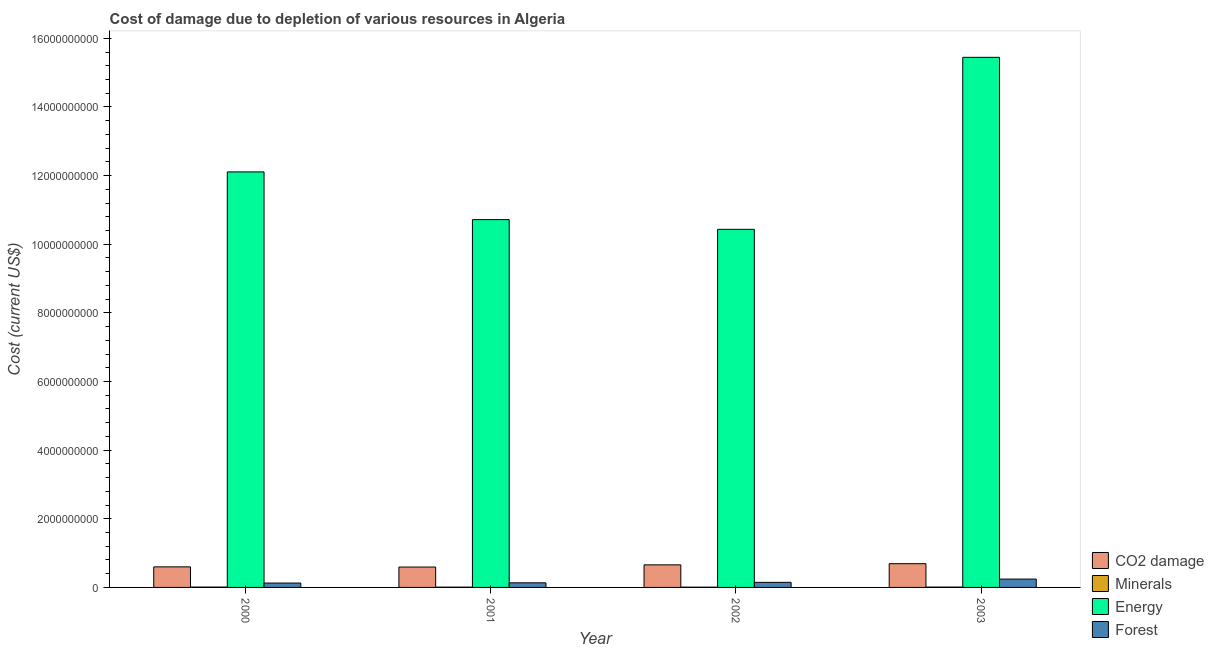How many different coloured bars are there?
Provide a succinct answer. 4. How many groups of bars are there?
Offer a terse response. 4. How many bars are there on the 2nd tick from the left?
Offer a terse response. 4. What is the label of the 1st group of bars from the left?
Keep it short and to the point. 2000. In how many cases, is the number of bars for a given year not equal to the number of legend labels?
Your answer should be compact. 0. What is the cost of damage due to depletion of energy in 2003?
Ensure brevity in your answer.  1.54e+1. Across all years, what is the maximum cost of damage due to depletion of forests?
Give a very brief answer. 2.43e+08. Across all years, what is the minimum cost of damage due to depletion of forests?
Offer a terse response. 1.27e+08. What is the total cost of damage due to depletion of forests in the graph?
Provide a succinct answer. 6.53e+08. What is the difference between the cost of damage due to depletion of energy in 2000 and that in 2002?
Make the answer very short. 1.67e+09. What is the difference between the cost of damage due to depletion of coal in 2001 and the cost of damage due to depletion of minerals in 2002?
Ensure brevity in your answer.  -6.37e+07. What is the average cost of damage due to depletion of energy per year?
Your answer should be very brief. 1.22e+1. In the year 2001, what is the difference between the cost of damage due to depletion of forests and cost of damage due to depletion of energy?
Offer a very short reply. 0. In how many years, is the cost of damage due to depletion of forests greater than 13600000000 US$?
Your response must be concise. 0. What is the ratio of the cost of damage due to depletion of energy in 2002 to that in 2003?
Your response must be concise. 0.68. What is the difference between the highest and the second highest cost of damage due to depletion of minerals?
Provide a succinct answer. 5.20e+05. What is the difference between the highest and the lowest cost of damage due to depletion of energy?
Ensure brevity in your answer.  5.01e+09. In how many years, is the cost of damage due to depletion of minerals greater than the average cost of damage due to depletion of minerals taken over all years?
Make the answer very short. 2. Is the sum of the cost of damage due to depletion of energy in 2002 and 2003 greater than the maximum cost of damage due to depletion of minerals across all years?
Keep it short and to the point. Yes. What does the 3rd bar from the left in 2001 represents?
Make the answer very short. Energy. What does the 3rd bar from the right in 2003 represents?
Provide a succinct answer. Minerals. Is it the case that in every year, the sum of the cost of damage due to depletion of coal and cost of damage due to depletion of minerals is greater than the cost of damage due to depletion of energy?
Provide a succinct answer. No. How many bars are there?
Keep it short and to the point. 16. Are all the bars in the graph horizontal?
Provide a short and direct response. No. How many years are there in the graph?
Offer a very short reply. 4. What is the difference between two consecutive major ticks on the Y-axis?
Provide a short and direct response. 2.00e+09. Are the values on the major ticks of Y-axis written in scientific E-notation?
Ensure brevity in your answer.  No. Where does the legend appear in the graph?
Your answer should be very brief. Bottom right. How are the legend labels stacked?
Your response must be concise. Vertical. What is the title of the graph?
Offer a very short reply. Cost of damage due to depletion of various resources in Algeria . What is the label or title of the X-axis?
Offer a terse response. Year. What is the label or title of the Y-axis?
Your response must be concise. Cost (current US$). What is the Cost (current US$) in CO2 damage in 2000?
Give a very brief answer. 5.99e+08. What is the Cost (current US$) of Minerals in 2000?
Ensure brevity in your answer.  9.70e+06. What is the Cost (current US$) of Energy in 2000?
Your answer should be compact. 1.21e+1. What is the Cost (current US$) of Forest in 2000?
Offer a terse response. 1.27e+08. What is the Cost (current US$) of CO2 damage in 2001?
Offer a very short reply. 5.94e+08. What is the Cost (current US$) of Minerals in 2001?
Your answer should be compact. 8.20e+06. What is the Cost (current US$) in Energy in 2001?
Your response must be concise. 1.07e+1. What is the Cost (current US$) of Forest in 2001?
Give a very brief answer. 1.34e+08. What is the Cost (current US$) of CO2 damage in 2002?
Your answer should be very brief. 6.58e+08. What is the Cost (current US$) in Minerals in 2002?
Your response must be concise. 7.85e+06. What is the Cost (current US$) of Energy in 2002?
Offer a terse response. 1.04e+1. What is the Cost (current US$) in Forest in 2002?
Make the answer very short. 1.48e+08. What is the Cost (current US$) of CO2 damage in 2003?
Your answer should be very brief. 6.91e+08. What is the Cost (current US$) in Minerals in 2003?
Make the answer very short. 1.02e+07. What is the Cost (current US$) of Energy in 2003?
Ensure brevity in your answer.  1.54e+1. What is the Cost (current US$) in Forest in 2003?
Provide a short and direct response. 2.43e+08. Across all years, what is the maximum Cost (current US$) of CO2 damage?
Make the answer very short. 6.91e+08. Across all years, what is the maximum Cost (current US$) in Minerals?
Provide a succinct answer. 1.02e+07. Across all years, what is the maximum Cost (current US$) of Energy?
Provide a succinct answer. 1.54e+1. Across all years, what is the maximum Cost (current US$) of Forest?
Offer a very short reply. 2.43e+08. Across all years, what is the minimum Cost (current US$) in CO2 damage?
Offer a terse response. 5.94e+08. Across all years, what is the minimum Cost (current US$) in Minerals?
Offer a very short reply. 7.85e+06. Across all years, what is the minimum Cost (current US$) in Energy?
Provide a succinct answer. 1.04e+1. Across all years, what is the minimum Cost (current US$) in Forest?
Give a very brief answer. 1.27e+08. What is the total Cost (current US$) of CO2 damage in the graph?
Ensure brevity in your answer.  2.54e+09. What is the total Cost (current US$) in Minerals in the graph?
Your answer should be compact. 3.60e+07. What is the total Cost (current US$) of Energy in the graph?
Offer a terse response. 4.87e+1. What is the total Cost (current US$) of Forest in the graph?
Keep it short and to the point. 6.53e+08. What is the difference between the Cost (current US$) of CO2 damage in 2000 and that in 2001?
Your answer should be very brief. 4.80e+06. What is the difference between the Cost (current US$) in Minerals in 2000 and that in 2001?
Your answer should be very brief. 1.50e+06. What is the difference between the Cost (current US$) in Energy in 2000 and that in 2001?
Provide a short and direct response. 1.39e+09. What is the difference between the Cost (current US$) of Forest in 2000 and that in 2001?
Your response must be concise. -6.78e+06. What is the difference between the Cost (current US$) of CO2 damage in 2000 and that in 2002?
Give a very brief answer. -5.89e+07. What is the difference between the Cost (current US$) in Minerals in 2000 and that in 2002?
Make the answer very short. 1.84e+06. What is the difference between the Cost (current US$) of Energy in 2000 and that in 2002?
Ensure brevity in your answer.  1.67e+09. What is the difference between the Cost (current US$) of Forest in 2000 and that in 2002?
Provide a short and direct response. -2.07e+07. What is the difference between the Cost (current US$) of CO2 damage in 2000 and that in 2003?
Your answer should be compact. -9.25e+07. What is the difference between the Cost (current US$) of Minerals in 2000 and that in 2003?
Make the answer very short. -5.20e+05. What is the difference between the Cost (current US$) of Energy in 2000 and that in 2003?
Provide a succinct answer. -3.34e+09. What is the difference between the Cost (current US$) of Forest in 2000 and that in 2003?
Keep it short and to the point. -1.16e+08. What is the difference between the Cost (current US$) of CO2 damage in 2001 and that in 2002?
Provide a short and direct response. -6.37e+07. What is the difference between the Cost (current US$) in Minerals in 2001 and that in 2002?
Offer a terse response. 3.41e+05. What is the difference between the Cost (current US$) of Energy in 2001 and that in 2002?
Ensure brevity in your answer.  2.84e+08. What is the difference between the Cost (current US$) in Forest in 2001 and that in 2002?
Provide a succinct answer. -1.39e+07. What is the difference between the Cost (current US$) in CO2 damage in 2001 and that in 2003?
Ensure brevity in your answer.  -9.73e+07. What is the difference between the Cost (current US$) in Minerals in 2001 and that in 2003?
Provide a succinct answer. -2.02e+06. What is the difference between the Cost (current US$) of Energy in 2001 and that in 2003?
Make the answer very short. -4.73e+09. What is the difference between the Cost (current US$) of Forest in 2001 and that in 2003?
Provide a short and direct response. -1.09e+08. What is the difference between the Cost (current US$) of CO2 damage in 2002 and that in 2003?
Keep it short and to the point. -3.36e+07. What is the difference between the Cost (current US$) of Minerals in 2002 and that in 2003?
Offer a terse response. -2.36e+06. What is the difference between the Cost (current US$) of Energy in 2002 and that in 2003?
Provide a succinct answer. -5.01e+09. What is the difference between the Cost (current US$) in Forest in 2002 and that in 2003?
Give a very brief answer. -9.53e+07. What is the difference between the Cost (current US$) of CO2 damage in 2000 and the Cost (current US$) of Minerals in 2001?
Your response must be concise. 5.91e+08. What is the difference between the Cost (current US$) of CO2 damage in 2000 and the Cost (current US$) of Energy in 2001?
Your answer should be very brief. -1.01e+1. What is the difference between the Cost (current US$) in CO2 damage in 2000 and the Cost (current US$) in Forest in 2001?
Offer a terse response. 4.65e+08. What is the difference between the Cost (current US$) in Minerals in 2000 and the Cost (current US$) in Energy in 2001?
Provide a short and direct response. -1.07e+1. What is the difference between the Cost (current US$) of Minerals in 2000 and the Cost (current US$) of Forest in 2001?
Your answer should be very brief. -1.24e+08. What is the difference between the Cost (current US$) in Energy in 2000 and the Cost (current US$) in Forest in 2001?
Your answer should be compact. 1.20e+1. What is the difference between the Cost (current US$) in CO2 damage in 2000 and the Cost (current US$) in Minerals in 2002?
Give a very brief answer. 5.91e+08. What is the difference between the Cost (current US$) in CO2 damage in 2000 and the Cost (current US$) in Energy in 2002?
Make the answer very short. -9.84e+09. What is the difference between the Cost (current US$) in CO2 damage in 2000 and the Cost (current US$) in Forest in 2002?
Give a very brief answer. 4.51e+08. What is the difference between the Cost (current US$) of Minerals in 2000 and the Cost (current US$) of Energy in 2002?
Give a very brief answer. -1.04e+1. What is the difference between the Cost (current US$) of Minerals in 2000 and the Cost (current US$) of Forest in 2002?
Your response must be concise. -1.38e+08. What is the difference between the Cost (current US$) of Energy in 2000 and the Cost (current US$) of Forest in 2002?
Offer a very short reply. 1.20e+1. What is the difference between the Cost (current US$) of CO2 damage in 2000 and the Cost (current US$) of Minerals in 2003?
Your answer should be very brief. 5.89e+08. What is the difference between the Cost (current US$) in CO2 damage in 2000 and the Cost (current US$) in Energy in 2003?
Ensure brevity in your answer.  -1.48e+1. What is the difference between the Cost (current US$) in CO2 damage in 2000 and the Cost (current US$) in Forest in 2003?
Offer a very short reply. 3.56e+08. What is the difference between the Cost (current US$) of Minerals in 2000 and the Cost (current US$) of Energy in 2003?
Offer a terse response. -1.54e+1. What is the difference between the Cost (current US$) of Minerals in 2000 and the Cost (current US$) of Forest in 2003?
Give a very brief answer. -2.34e+08. What is the difference between the Cost (current US$) in Energy in 2000 and the Cost (current US$) in Forest in 2003?
Give a very brief answer. 1.19e+1. What is the difference between the Cost (current US$) in CO2 damage in 2001 and the Cost (current US$) in Minerals in 2002?
Provide a succinct answer. 5.86e+08. What is the difference between the Cost (current US$) of CO2 damage in 2001 and the Cost (current US$) of Energy in 2002?
Provide a succinct answer. -9.84e+09. What is the difference between the Cost (current US$) in CO2 damage in 2001 and the Cost (current US$) in Forest in 2002?
Offer a very short reply. 4.46e+08. What is the difference between the Cost (current US$) of Minerals in 2001 and the Cost (current US$) of Energy in 2002?
Ensure brevity in your answer.  -1.04e+1. What is the difference between the Cost (current US$) in Minerals in 2001 and the Cost (current US$) in Forest in 2002?
Provide a succinct answer. -1.40e+08. What is the difference between the Cost (current US$) in Energy in 2001 and the Cost (current US$) in Forest in 2002?
Ensure brevity in your answer.  1.06e+1. What is the difference between the Cost (current US$) of CO2 damage in 2001 and the Cost (current US$) of Minerals in 2003?
Offer a terse response. 5.84e+08. What is the difference between the Cost (current US$) in CO2 damage in 2001 and the Cost (current US$) in Energy in 2003?
Offer a very short reply. -1.49e+1. What is the difference between the Cost (current US$) in CO2 damage in 2001 and the Cost (current US$) in Forest in 2003?
Your response must be concise. 3.51e+08. What is the difference between the Cost (current US$) of Minerals in 2001 and the Cost (current US$) of Energy in 2003?
Your response must be concise. -1.54e+1. What is the difference between the Cost (current US$) of Minerals in 2001 and the Cost (current US$) of Forest in 2003?
Make the answer very short. -2.35e+08. What is the difference between the Cost (current US$) in Energy in 2001 and the Cost (current US$) in Forest in 2003?
Give a very brief answer. 1.05e+1. What is the difference between the Cost (current US$) in CO2 damage in 2002 and the Cost (current US$) in Minerals in 2003?
Offer a terse response. 6.48e+08. What is the difference between the Cost (current US$) of CO2 damage in 2002 and the Cost (current US$) of Energy in 2003?
Provide a succinct answer. -1.48e+1. What is the difference between the Cost (current US$) in CO2 damage in 2002 and the Cost (current US$) in Forest in 2003?
Give a very brief answer. 4.14e+08. What is the difference between the Cost (current US$) of Minerals in 2002 and the Cost (current US$) of Energy in 2003?
Keep it short and to the point. -1.54e+1. What is the difference between the Cost (current US$) in Minerals in 2002 and the Cost (current US$) in Forest in 2003?
Give a very brief answer. -2.35e+08. What is the difference between the Cost (current US$) in Energy in 2002 and the Cost (current US$) in Forest in 2003?
Give a very brief answer. 1.02e+1. What is the average Cost (current US$) in CO2 damage per year?
Your answer should be compact. 6.36e+08. What is the average Cost (current US$) in Minerals per year?
Keep it short and to the point. 8.99e+06. What is the average Cost (current US$) in Energy per year?
Your answer should be compact. 1.22e+1. What is the average Cost (current US$) of Forest per year?
Your response must be concise. 1.63e+08. In the year 2000, what is the difference between the Cost (current US$) in CO2 damage and Cost (current US$) in Minerals?
Provide a succinct answer. 5.89e+08. In the year 2000, what is the difference between the Cost (current US$) in CO2 damage and Cost (current US$) in Energy?
Keep it short and to the point. -1.15e+1. In the year 2000, what is the difference between the Cost (current US$) in CO2 damage and Cost (current US$) in Forest?
Offer a terse response. 4.72e+08. In the year 2000, what is the difference between the Cost (current US$) in Minerals and Cost (current US$) in Energy?
Offer a terse response. -1.21e+1. In the year 2000, what is the difference between the Cost (current US$) of Minerals and Cost (current US$) of Forest?
Your answer should be compact. -1.18e+08. In the year 2000, what is the difference between the Cost (current US$) of Energy and Cost (current US$) of Forest?
Ensure brevity in your answer.  1.20e+1. In the year 2001, what is the difference between the Cost (current US$) in CO2 damage and Cost (current US$) in Minerals?
Make the answer very short. 5.86e+08. In the year 2001, what is the difference between the Cost (current US$) in CO2 damage and Cost (current US$) in Energy?
Your answer should be very brief. -1.01e+1. In the year 2001, what is the difference between the Cost (current US$) of CO2 damage and Cost (current US$) of Forest?
Offer a very short reply. 4.60e+08. In the year 2001, what is the difference between the Cost (current US$) of Minerals and Cost (current US$) of Energy?
Keep it short and to the point. -1.07e+1. In the year 2001, what is the difference between the Cost (current US$) of Minerals and Cost (current US$) of Forest?
Provide a succinct answer. -1.26e+08. In the year 2001, what is the difference between the Cost (current US$) of Energy and Cost (current US$) of Forest?
Provide a short and direct response. 1.06e+1. In the year 2002, what is the difference between the Cost (current US$) in CO2 damage and Cost (current US$) in Minerals?
Your response must be concise. 6.50e+08. In the year 2002, what is the difference between the Cost (current US$) in CO2 damage and Cost (current US$) in Energy?
Offer a terse response. -9.78e+09. In the year 2002, what is the difference between the Cost (current US$) of CO2 damage and Cost (current US$) of Forest?
Make the answer very short. 5.10e+08. In the year 2002, what is the difference between the Cost (current US$) in Minerals and Cost (current US$) in Energy?
Provide a succinct answer. -1.04e+1. In the year 2002, what is the difference between the Cost (current US$) in Minerals and Cost (current US$) in Forest?
Offer a terse response. -1.40e+08. In the year 2002, what is the difference between the Cost (current US$) in Energy and Cost (current US$) in Forest?
Your answer should be compact. 1.03e+1. In the year 2003, what is the difference between the Cost (current US$) of CO2 damage and Cost (current US$) of Minerals?
Ensure brevity in your answer.  6.81e+08. In the year 2003, what is the difference between the Cost (current US$) of CO2 damage and Cost (current US$) of Energy?
Offer a very short reply. -1.48e+1. In the year 2003, what is the difference between the Cost (current US$) of CO2 damage and Cost (current US$) of Forest?
Provide a succinct answer. 4.48e+08. In the year 2003, what is the difference between the Cost (current US$) of Minerals and Cost (current US$) of Energy?
Your response must be concise. -1.54e+1. In the year 2003, what is the difference between the Cost (current US$) of Minerals and Cost (current US$) of Forest?
Offer a very short reply. -2.33e+08. In the year 2003, what is the difference between the Cost (current US$) in Energy and Cost (current US$) in Forest?
Make the answer very short. 1.52e+1. What is the ratio of the Cost (current US$) of Minerals in 2000 to that in 2001?
Give a very brief answer. 1.18. What is the ratio of the Cost (current US$) in Energy in 2000 to that in 2001?
Provide a short and direct response. 1.13. What is the ratio of the Cost (current US$) of Forest in 2000 to that in 2001?
Offer a terse response. 0.95. What is the ratio of the Cost (current US$) of CO2 damage in 2000 to that in 2002?
Offer a very short reply. 0.91. What is the ratio of the Cost (current US$) in Minerals in 2000 to that in 2002?
Give a very brief answer. 1.23. What is the ratio of the Cost (current US$) in Energy in 2000 to that in 2002?
Keep it short and to the point. 1.16. What is the ratio of the Cost (current US$) of Forest in 2000 to that in 2002?
Ensure brevity in your answer.  0.86. What is the ratio of the Cost (current US$) in CO2 damage in 2000 to that in 2003?
Keep it short and to the point. 0.87. What is the ratio of the Cost (current US$) of Minerals in 2000 to that in 2003?
Provide a succinct answer. 0.95. What is the ratio of the Cost (current US$) in Energy in 2000 to that in 2003?
Your answer should be compact. 0.78. What is the ratio of the Cost (current US$) in Forest in 2000 to that in 2003?
Make the answer very short. 0.52. What is the ratio of the Cost (current US$) in CO2 damage in 2001 to that in 2002?
Provide a short and direct response. 0.9. What is the ratio of the Cost (current US$) of Minerals in 2001 to that in 2002?
Provide a succinct answer. 1.04. What is the ratio of the Cost (current US$) in Energy in 2001 to that in 2002?
Give a very brief answer. 1.03. What is the ratio of the Cost (current US$) of Forest in 2001 to that in 2002?
Give a very brief answer. 0.91. What is the ratio of the Cost (current US$) in CO2 damage in 2001 to that in 2003?
Give a very brief answer. 0.86. What is the ratio of the Cost (current US$) in Minerals in 2001 to that in 2003?
Make the answer very short. 0.8. What is the ratio of the Cost (current US$) of Energy in 2001 to that in 2003?
Your response must be concise. 0.69. What is the ratio of the Cost (current US$) of Forest in 2001 to that in 2003?
Provide a succinct answer. 0.55. What is the ratio of the Cost (current US$) of CO2 damage in 2002 to that in 2003?
Keep it short and to the point. 0.95. What is the ratio of the Cost (current US$) in Minerals in 2002 to that in 2003?
Your response must be concise. 0.77. What is the ratio of the Cost (current US$) of Energy in 2002 to that in 2003?
Your answer should be very brief. 0.68. What is the ratio of the Cost (current US$) of Forest in 2002 to that in 2003?
Your answer should be very brief. 0.61. What is the difference between the highest and the second highest Cost (current US$) of CO2 damage?
Your answer should be very brief. 3.36e+07. What is the difference between the highest and the second highest Cost (current US$) of Minerals?
Ensure brevity in your answer.  5.20e+05. What is the difference between the highest and the second highest Cost (current US$) of Energy?
Offer a very short reply. 3.34e+09. What is the difference between the highest and the second highest Cost (current US$) in Forest?
Your answer should be very brief. 9.53e+07. What is the difference between the highest and the lowest Cost (current US$) in CO2 damage?
Keep it short and to the point. 9.73e+07. What is the difference between the highest and the lowest Cost (current US$) in Minerals?
Provide a succinct answer. 2.36e+06. What is the difference between the highest and the lowest Cost (current US$) of Energy?
Provide a succinct answer. 5.01e+09. What is the difference between the highest and the lowest Cost (current US$) of Forest?
Your answer should be very brief. 1.16e+08. 